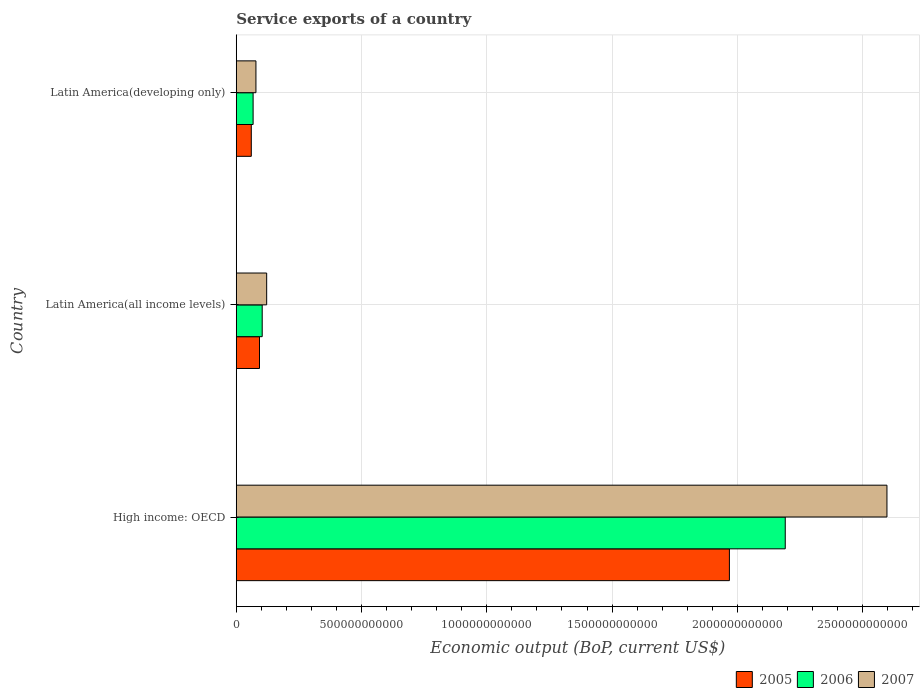How many different coloured bars are there?
Provide a short and direct response. 3. Are the number of bars on each tick of the Y-axis equal?
Provide a short and direct response. Yes. How many bars are there on the 1st tick from the bottom?
Provide a short and direct response. 3. What is the label of the 3rd group of bars from the top?
Your answer should be compact. High income: OECD. In how many cases, is the number of bars for a given country not equal to the number of legend labels?
Your answer should be compact. 0. What is the service exports in 2005 in Latin America(all income levels)?
Keep it short and to the point. 9.28e+1. Across all countries, what is the maximum service exports in 2007?
Keep it short and to the point. 2.60e+12. Across all countries, what is the minimum service exports in 2007?
Offer a very short reply. 7.86e+1. In which country was the service exports in 2007 maximum?
Provide a succinct answer. High income: OECD. In which country was the service exports in 2007 minimum?
Your response must be concise. Latin America(developing only). What is the total service exports in 2007 in the graph?
Offer a terse response. 2.80e+12. What is the difference between the service exports in 2006 in High income: OECD and that in Latin America(developing only)?
Keep it short and to the point. 2.12e+12. What is the difference between the service exports in 2006 in Latin America(all income levels) and the service exports in 2007 in Latin America(developing only)?
Your answer should be compact. 2.50e+1. What is the average service exports in 2005 per country?
Offer a terse response. 7.07e+11. What is the difference between the service exports in 2005 and service exports in 2007 in Latin America(developing only)?
Provide a short and direct response. -1.86e+1. In how many countries, is the service exports in 2005 greater than 100000000000 US$?
Keep it short and to the point. 1. What is the ratio of the service exports in 2007 in High income: OECD to that in Latin America(all income levels)?
Make the answer very short. 21.39. Is the difference between the service exports in 2005 in High income: OECD and Latin America(all income levels) greater than the difference between the service exports in 2007 in High income: OECD and Latin America(all income levels)?
Provide a short and direct response. No. What is the difference between the highest and the second highest service exports in 2006?
Your response must be concise. 2.09e+12. What is the difference between the highest and the lowest service exports in 2007?
Make the answer very short. 2.52e+12. In how many countries, is the service exports in 2005 greater than the average service exports in 2005 taken over all countries?
Provide a short and direct response. 1. Is the sum of the service exports in 2007 in Latin America(all income levels) and Latin America(developing only) greater than the maximum service exports in 2006 across all countries?
Provide a succinct answer. No. Is it the case that in every country, the sum of the service exports in 2007 and service exports in 2006 is greater than the service exports in 2005?
Ensure brevity in your answer.  Yes. What is the difference between two consecutive major ticks on the X-axis?
Your answer should be compact. 5.00e+11. Does the graph contain grids?
Keep it short and to the point. Yes. How are the legend labels stacked?
Give a very brief answer. Horizontal. What is the title of the graph?
Offer a terse response. Service exports of a country. What is the label or title of the X-axis?
Provide a succinct answer. Economic output (BoP, current US$). What is the Economic output (BoP, current US$) of 2005 in High income: OECD?
Give a very brief answer. 1.97e+12. What is the Economic output (BoP, current US$) of 2006 in High income: OECD?
Offer a terse response. 2.19e+12. What is the Economic output (BoP, current US$) in 2007 in High income: OECD?
Keep it short and to the point. 2.60e+12. What is the Economic output (BoP, current US$) of 2005 in Latin America(all income levels)?
Offer a very short reply. 9.28e+1. What is the Economic output (BoP, current US$) of 2006 in Latin America(all income levels)?
Your response must be concise. 1.04e+11. What is the Economic output (BoP, current US$) of 2007 in Latin America(all income levels)?
Provide a short and direct response. 1.21e+11. What is the Economic output (BoP, current US$) in 2005 in Latin America(developing only)?
Your answer should be very brief. 6.00e+1. What is the Economic output (BoP, current US$) of 2006 in Latin America(developing only)?
Your answer should be very brief. 6.73e+1. What is the Economic output (BoP, current US$) in 2007 in Latin America(developing only)?
Provide a short and direct response. 7.86e+1. Across all countries, what is the maximum Economic output (BoP, current US$) in 2005?
Provide a succinct answer. 1.97e+12. Across all countries, what is the maximum Economic output (BoP, current US$) of 2006?
Ensure brevity in your answer.  2.19e+12. Across all countries, what is the maximum Economic output (BoP, current US$) in 2007?
Your answer should be very brief. 2.60e+12. Across all countries, what is the minimum Economic output (BoP, current US$) in 2005?
Your answer should be very brief. 6.00e+1. Across all countries, what is the minimum Economic output (BoP, current US$) of 2006?
Provide a short and direct response. 6.73e+1. Across all countries, what is the minimum Economic output (BoP, current US$) of 2007?
Your response must be concise. 7.86e+1. What is the total Economic output (BoP, current US$) of 2005 in the graph?
Offer a terse response. 2.12e+12. What is the total Economic output (BoP, current US$) in 2006 in the graph?
Make the answer very short. 2.36e+12. What is the total Economic output (BoP, current US$) of 2007 in the graph?
Your answer should be compact. 2.80e+12. What is the difference between the Economic output (BoP, current US$) of 2005 in High income: OECD and that in Latin America(all income levels)?
Keep it short and to the point. 1.88e+12. What is the difference between the Economic output (BoP, current US$) in 2006 in High income: OECD and that in Latin America(all income levels)?
Offer a very short reply. 2.09e+12. What is the difference between the Economic output (BoP, current US$) in 2007 in High income: OECD and that in Latin America(all income levels)?
Provide a short and direct response. 2.48e+12. What is the difference between the Economic output (BoP, current US$) of 2005 in High income: OECD and that in Latin America(developing only)?
Provide a short and direct response. 1.91e+12. What is the difference between the Economic output (BoP, current US$) of 2006 in High income: OECD and that in Latin America(developing only)?
Ensure brevity in your answer.  2.12e+12. What is the difference between the Economic output (BoP, current US$) in 2007 in High income: OECD and that in Latin America(developing only)?
Offer a terse response. 2.52e+12. What is the difference between the Economic output (BoP, current US$) of 2005 in Latin America(all income levels) and that in Latin America(developing only)?
Offer a very short reply. 3.27e+1. What is the difference between the Economic output (BoP, current US$) of 2006 in Latin America(all income levels) and that in Latin America(developing only)?
Provide a succinct answer. 3.62e+1. What is the difference between the Economic output (BoP, current US$) of 2007 in Latin America(all income levels) and that in Latin America(developing only)?
Offer a very short reply. 4.29e+1. What is the difference between the Economic output (BoP, current US$) of 2005 in High income: OECD and the Economic output (BoP, current US$) of 2006 in Latin America(all income levels)?
Offer a very short reply. 1.86e+12. What is the difference between the Economic output (BoP, current US$) of 2005 in High income: OECD and the Economic output (BoP, current US$) of 2007 in Latin America(all income levels)?
Your response must be concise. 1.85e+12. What is the difference between the Economic output (BoP, current US$) in 2006 in High income: OECD and the Economic output (BoP, current US$) in 2007 in Latin America(all income levels)?
Ensure brevity in your answer.  2.07e+12. What is the difference between the Economic output (BoP, current US$) in 2005 in High income: OECD and the Economic output (BoP, current US$) in 2006 in Latin America(developing only)?
Keep it short and to the point. 1.90e+12. What is the difference between the Economic output (BoP, current US$) in 2005 in High income: OECD and the Economic output (BoP, current US$) in 2007 in Latin America(developing only)?
Your response must be concise. 1.89e+12. What is the difference between the Economic output (BoP, current US$) of 2006 in High income: OECD and the Economic output (BoP, current US$) of 2007 in Latin America(developing only)?
Ensure brevity in your answer.  2.11e+12. What is the difference between the Economic output (BoP, current US$) in 2005 in Latin America(all income levels) and the Economic output (BoP, current US$) in 2006 in Latin America(developing only)?
Offer a very short reply. 2.55e+1. What is the difference between the Economic output (BoP, current US$) in 2005 in Latin America(all income levels) and the Economic output (BoP, current US$) in 2007 in Latin America(developing only)?
Give a very brief answer. 1.42e+1. What is the difference between the Economic output (BoP, current US$) in 2006 in Latin America(all income levels) and the Economic output (BoP, current US$) in 2007 in Latin America(developing only)?
Offer a terse response. 2.50e+1. What is the average Economic output (BoP, current US$) of 2005 per country?
Your response must be concise. 7.07e+11. What is the average Economic output (BoP, current US$) in 2006 per country?
Give a very brief answer. 7.87e+11. What is the average Economic output (BoP, current US$) of 2007 per country?
Offer a very short reply. 9.32e+11. What is the difference between the Economic output (BoP, current US$) of 2005 and Economic output (BoP, current US$) of 2006 in High income: OECD?
Provide a succinct answer. -2.23e+11. What is the difference between the Economic output (BoP, current US$) in 2005 and Economic output (BoP, current US$) in 2007 in High income: OECD?
Offer a very short reply. -6.29e+11. What is the difference between the Economic output (BoP, current US$) of 2006 and Economic output (BoP, current US$) of 2007 in High income: OECD?
Your answer should be very brief. -4.06e+11. What is the difference between the Economic output (BoP, current US$) of 2005 and Economic output (BoP, current US$) of 2006 in Latin America(all income levels)?
Give a very brief answer. -1.08e+1. What is the difference between the Economic output (BoP, current US$) in 2005 and Economic output (BoP, current US$) in 2007 in Latin America(all income levels)?
Give a very brief answer. -2.87e+1. What is the difference between the Economic output (BoP, current US$) in 2006 and Economic output (BoP, current US$) in 2007 in Latin America(all income levels)?
Your answer should be compact. -1.79e+1. What is the difference between the Economic output (BoP, current US$) in 2005 and Economic output (BoP, current US$) in 2006 in Latin America(developing only)?
Your response must be concise. -7.28e+09. What is the difference between the Economic output (BoP, current US$) of 2005 and Economic output (BoP, current US$) of 2007 in Latin America(developing only)?
Ensure brevity in your answer.  -1.86e+1. What is the difference between the Economic output (BoP, current US$) in 2006 and Economic output (BoP, current US$) in 2007 in Latin America(developing only)?
Your answer should be very brief. -1.13e+1. What is the ratio of the Economic output (BoP, current US$) of 2005 in High income: OECD to that in Latin America(all income levels)?
Provide a short and direct response. 21.22. What is the ratio of the Economic output (BoP, current US$) in 2006 in High income: OECD to that in Latin America(all income levels)?
Ensure brevity in your answer.  21.16. What is the ratio of the Economic output (BoP, current US$) of 2007 in High income: OECD to that in Latin America(all income levels)?
Offer a very short reply. 21.39. What is the ratio of the Economic output (BoP, current US$) of 2005 in High income: OECD to that in Latin America(developing only)?
Your response must be concise. 32.79. What is the ratio of the Economic output (BoP, current US$) in 2006 in High income: OECD to that in Latin America(developing only)?
Provide a short and direct response. 32.56. What is the ratio of the Economic output (BoP, current US$) in 2007 in High income: OECD to that in Latin America(developing only)?
Offer a very short reply. 33.05. What is the ratio of the Economic output (BoP, current US$) of 2005 in Latin America(all income levels) to that in Latin America(developing only)?
Give a very brief answer. 1.55. What is the ratio of the Economic output (BoP, current US$) of 2006 in Latin America(all income levels) to that in Latin America(developing only)?
Ensure brevity in your answer.  1.54. What is the ratio of the Economic output (BoP, current US$) in 2007 in Latin America(all income levels) to that in Latin America(developing only)?
Ensure brevity in your answer.  1.55. What is the difference between the highest and the second highest Economic output (BoP, current US$) of 2005?
Provide a short and direct response. 1.88e+12. What is the difference between the highest and the second highest Economic output (BoP, current US$) of 2006?
Provide a short and direct response. 2.09e+12. What is the difference between the highest and the second highest Economic output (BoP, current US$) in 2007?
Offer a very short reply. 2.48e+12. What is the difference between the highest and the lowest Economic output (BoP, current US$) in 2005?
Offer a terse response. 1.91e+12. What is the difference between the highest and the lowest Economic output (BoP, current US$) in 2006?
Provide a succinct answer. 2.12e+12. What is the difference between the highest and the lowest Economic output (BoP, current US$) in 2007?
Keep it short and to the point. 2.52e+12. 